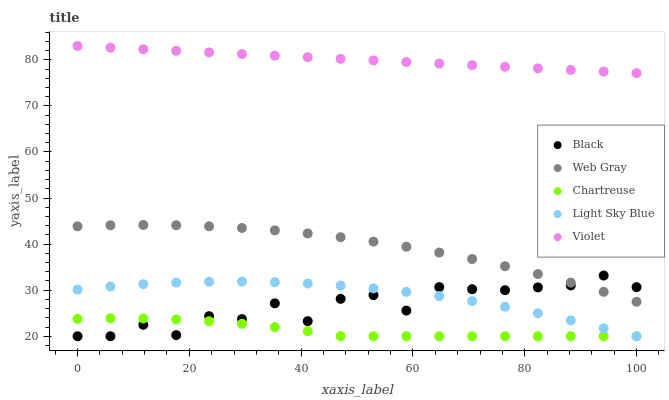Does Chartreuse have the minimum area under the curve?
Answer yes or no. Yes. Does Violet have the maximum area under the curve?
Answer yes or no. Yes. Does Web Gray have the minimum area under the curve?
Answer yes or no. No. Does Web Gray have the maximum area under the curve?
Answer yes or no. No. Is Violet the smoothest?
Answer yes or no. Yes. Is Black the roughest?
Answer yes or no. Yes. Is Web Gray the smoothest?
Answer yes or no. No. Is Web Gray the roughest?
Answer yes or no. No. Does Chartreuse have the lowest value?
Answer yes or no. Yes. Does Web Gray have the lowest value?
Answer yes or no. No. Does Violet have the highest value?
Answer yes or no. Yes. Does Web Gray have the highest value?
Answer yes or no. No. Is Black less than Violet?
Answer yes or no. Yes. Is Violet greater than Web Gray?
Answer yes or no. Yes. Does Black intersect Light Sky Blue?
Answer yes or no. Yes. Is Black less than Light Sky Blue?
Answer yes or no. No. Is Black greater than Light Sky Blue?
Answer yes or no. No. Does Black intersect Violet?
Answer yes or no. No. 